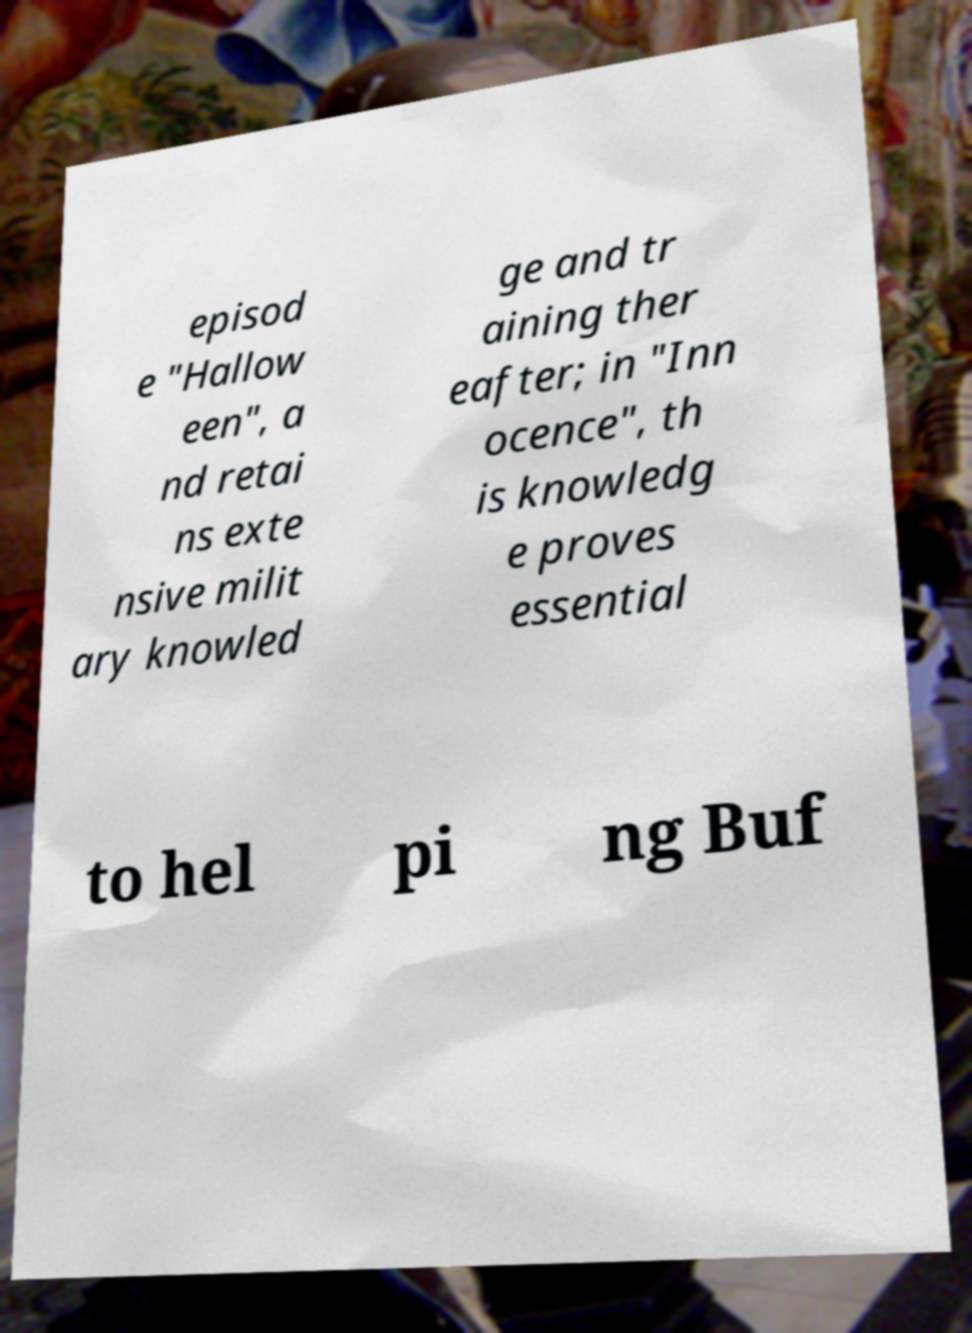What messages or text are displayed in this image? I need them in a readable, typed format. episod e "Hallow een", a nd retai ns exte nsive milit ary knowled ge and tr aining ther eafter; in "Inn ocence", th is knowledg e proves essential to hel pi ng Buf 